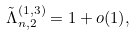<formula> <loc_0><loc_0><loc_500><loc_500>\tilde { \Lambda } _ { n , 2 } ^ { ( 1 , 3 ) } = 1 + o ( 1 ) ,</formula> 